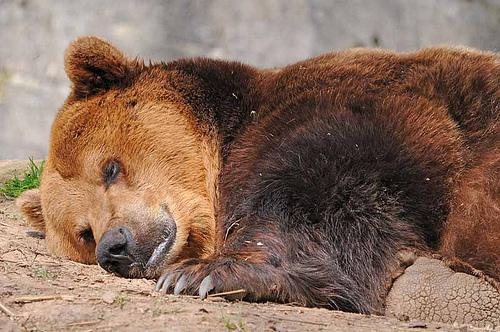Question: what animal is this?
Choices:
A. A lemur.
B. Bear.
C. An Armadillo.
D. A moose.
Answer with the letter. Answer: B Question: why is he on the ground?
Choices:
A. He is dead.
B. He is crawling under a fence.
C. Sleeping.
D. He is ill.
Answer with the letter. Answer: C Question: what are his paws like?
Choices:
A. Sharp.
B. Have claws.
C. Fuzzy.
D. Dirty.
Answer with the letter. Answer: B Question: how many ears are visible?
Choices:
A. One.
B. None.
C. Two.
D. Three.
Answer with the letter. Answer: C 